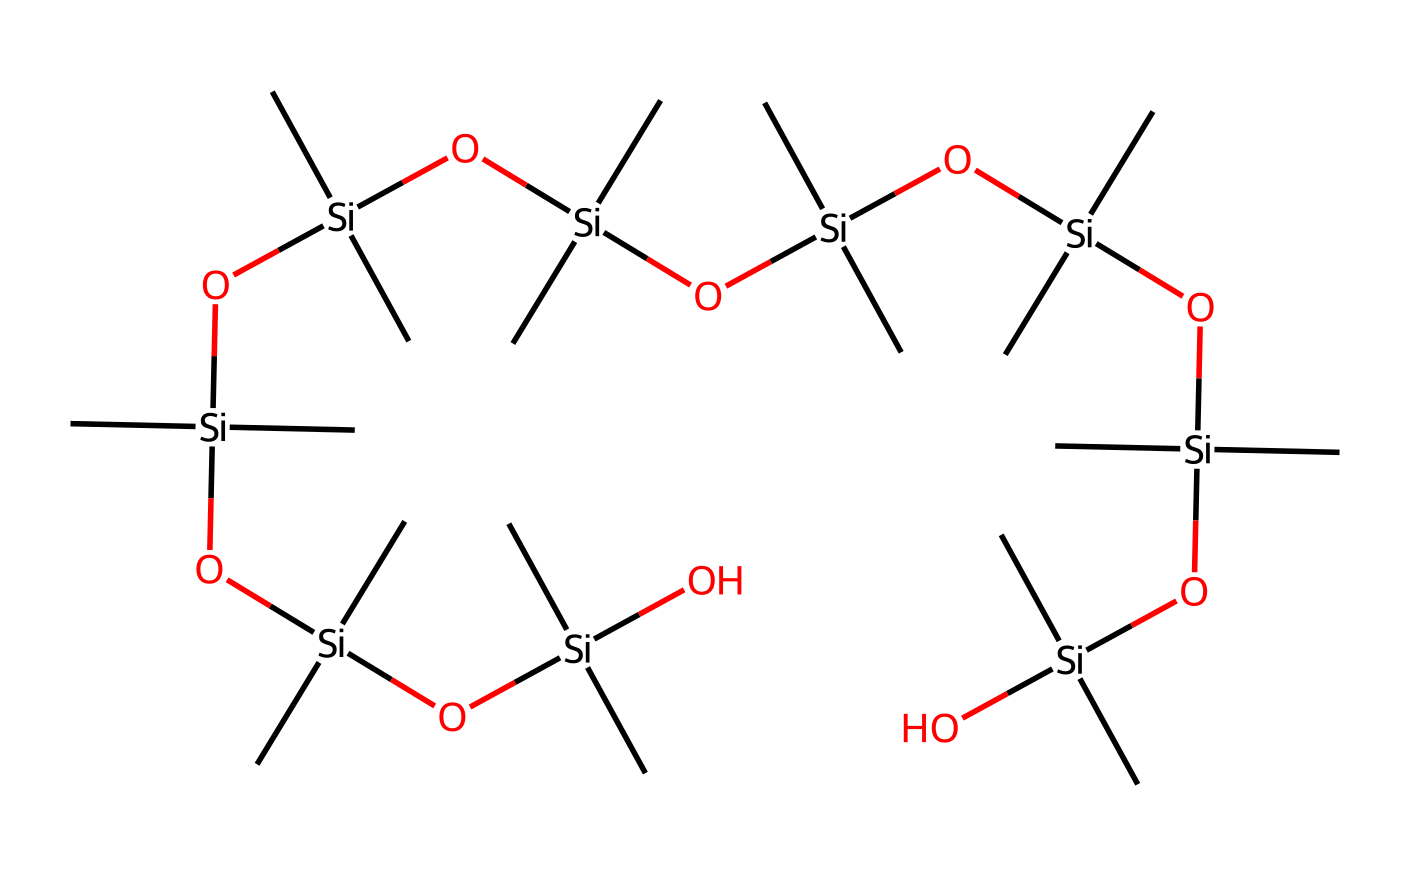What is the central atom in this chemical? The structure contains silicon atoms that are bonded to oxygen and carbon atoms, indicating that silicon is the central coordinating atom in this organosilicon compound.
Answer: silicon How many silicon atoms are present in this compound? By interpreting the SMILES representation, you can count the number of silicon atoms indicated, which appears to be 9 total.
Answer: 9 What type of bonds are predominantly found in this chemical? The chemical structure reveals that silicon is primarily forming covalent bonds with oxygen and carbon atoms, which is characteristic for organosilicon compounds.
Answer: covalent bonds What property does the presence of multiple siloxy groups contribute? The presence of multiple siloxy (Si-O) groups enhances thermal conductivity and flexibility in silicone-based thermal interface materials, which are essential for efficient heat transfer.
Answer: thermal conductivity What is the molecular formula for this chemical? By decoding the SMILES and counting the number of each type of atom present, the overall molecular formula can be deduced as C12H36O6Si8.
Answer: C12H36O6Si8 How does the structure indicate that this material is suitable for thermal interface applications? The high number of siloxy bonds and the extended polymeric structure allow for efficient thermal conductivity, making it suitable for thermal interface materials used in processors.
Answer: efficient thermal conductivity How many carbon atoms are present in this compound? By breaking down the structure represented in the SMILES, you can find that there are 12 carbon atoms included within the composition of the compound.
Answer: 12 